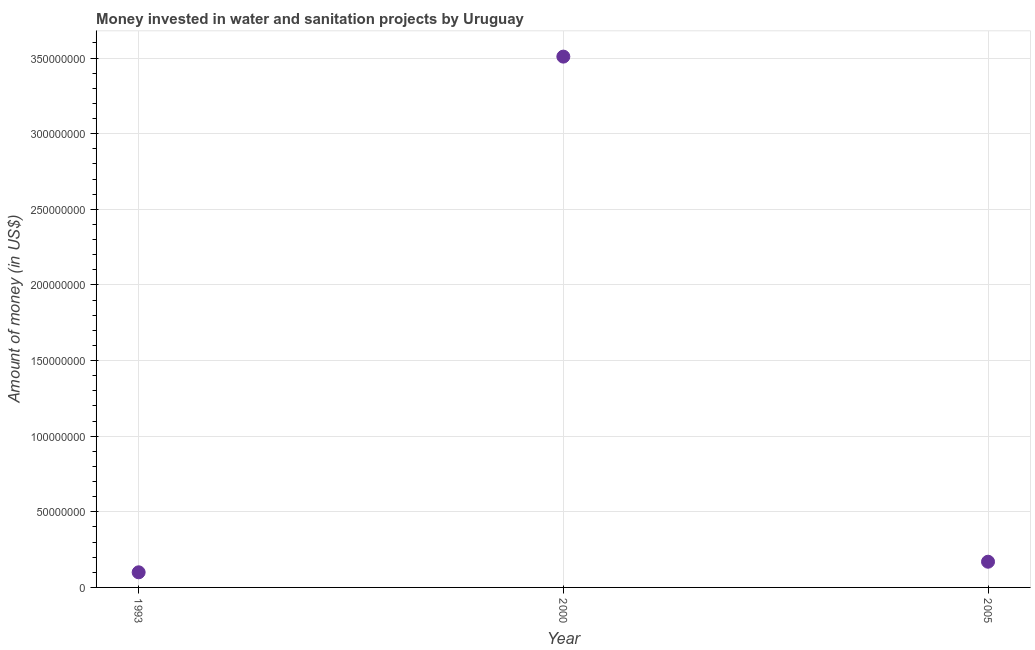What is the investment in 1993?
Keep it short and to the point. 1.00e+07. Across all years, what is the maximum investment?
Give a very brief answer. 3.51e+08. Across all years, what is the minimum investment?
Make the answer very short. 1.00e+07. In which year was the investment minimum?
Make the answer very short. 1993. What is the sum of the investment?
Keep it short and to the point. 3.78e+08. What is the difference between the investment in 1993 and 2000?
Provide a succinct answer. -3.41e+08. What is the average investment per year?
Ensure brevity in your answer.  1.26e+08. What is the median investment?
Your answer should be compact. 1.70e+07. In how many years, is the investment greater than 280000000 US$?
Ensure brevity in your answer.  1. Do a majority of the years between 2005 and 2000 (inclusive) have investment greater than 340000000 US$?
Keep it short and to the point. No. What is the ratio of the investment in 2000 to that in 2005?
Keep it short and to the point. 20.65. Is the investment in 1993 less than that in 2005?
Provide a succinct answer. Yes. Is the difference between the investment in 1993 and 2005 greater than the difference between any two years?
Your response must be concise. No. What is the difference between the highest and the second highest investment?
Make the answer very short. 3.34e+08. What is the difference between the highest and the lowest investment?
Ensure brevity in your answer.  3.41e+08. In how many years, is the investment greater than the average investment taken over all years?
Keep it short and to the point. 1. How many dotlines are there?
Provide a succinct answer. 1. What is the difference between two consecutive major ticks on the Y-axis?
Make the answer very short. 5.00e+07. Are the values on the major ticks of Y-axis written in scientific E-notation?
Keep it short and to the point. No. Does the graph contain grids?
Your answer should be very brief. Yes. What is the title of the graph?
Your answer should be very brief. Money invested in water and sanitation projects by Uruguay. What is the label or title of the X-axis?
Your answer should be compact. Year. What is the label or title of the Y-axis?
Your answer should be very brief. Amount of money (in US$). What is the Amount of money (in US$) in 2000?
Ensure brevity in your answer.  3.51e+08. What is the Amount of money (in US$) in 2005?
Ensure brevity in your answer.  1.70e+07. What is the difference between the Amount of money (in US$) in 1993 and 2000?
Your response must be concise. -3.41e+08. What is the difference between the Amount of money (in US$) in 1993 and 2005?
Your response must be concise. -7.00e+06. What is the difference between the Amount of money (in US$) in 2000 and 2005?
Your response must be concise. 3.34e+08. What is the ratio of the Amount of money (in US$) in 1993 to that in 2000?
Your response must be concise. 0.03. What is the ratio of the Amount of money (in US$) in 1993 to that in 2005?
Your answer should be compact. 0.59. What is the ratio of the Amount of money (in US$) in 2000 to that in 2005?
Your answer should be compact. 20.65. 